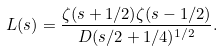<formula> <loc_0><loc_0><loc_500><loc_500>L ( s ) = \frac { \zeta ( s + 1 / 2 ) \zeta ( s - 1 / 2 ) } { D ( s / 2 + 1 / 4 ) ^ { 1 / 2 } } .</formula> 